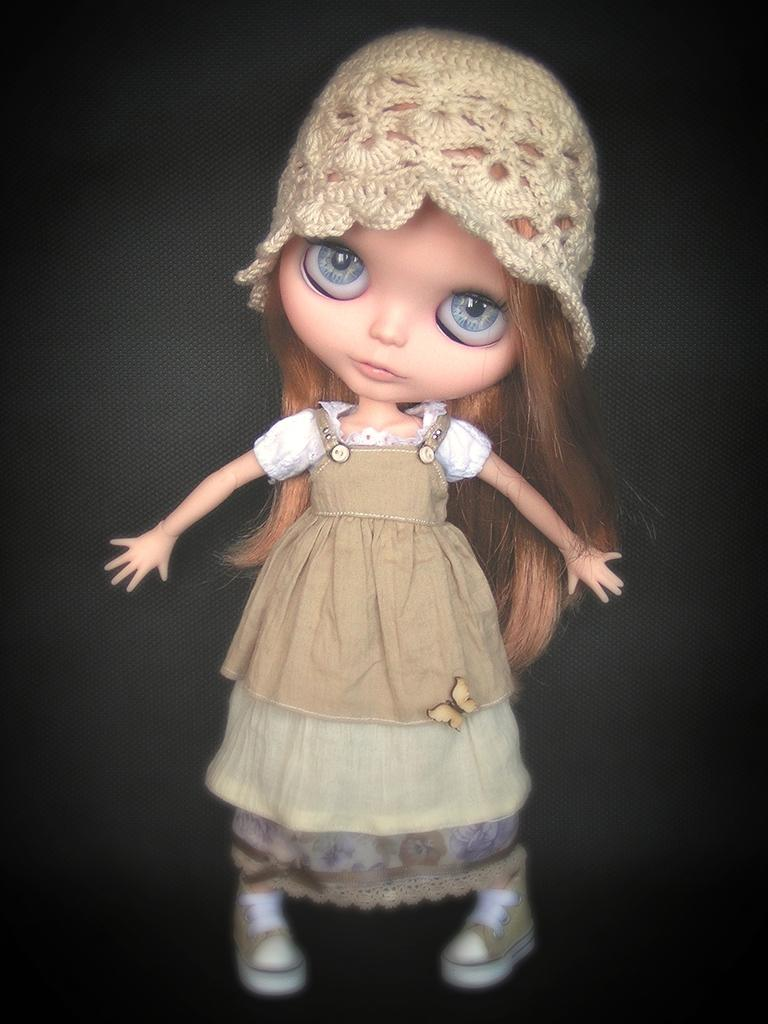What object can be seen in the image? There is a toy in the image. What color is the background of the image? The background of the image is black. Can you see the person's vein in the image? There is no person or vein present in the image; it features a toy against a black background. What type of animals can be seen at the zoo in the image? There is no zoo or animals present in the image; it features a toy against a black background. 